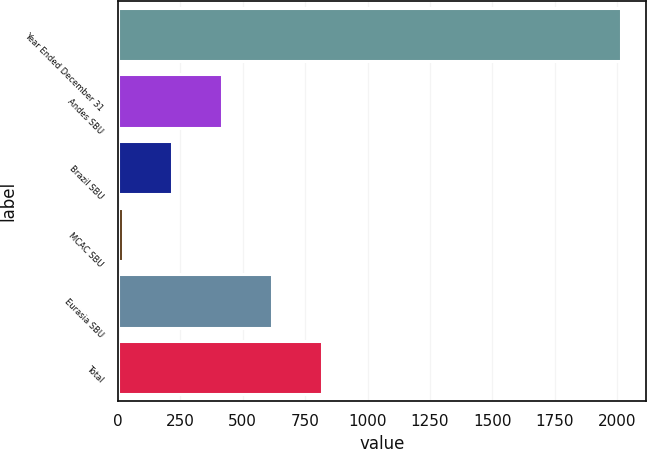Convert chart. <chart><loc_0><loc_0><loc_500><loc_500><bar_chart><fcel>Year Ended December 31<fcel>Andes SBU<fcel>Brazil SBU<fcel>MCAC SBU<fcel>Eurasia SBU<fcel>Total<nl><fcel>2017<fcel>417.8<fcel>217.9<fcel>18<fcel>617.7<fcel>817.6<nl></chart> 